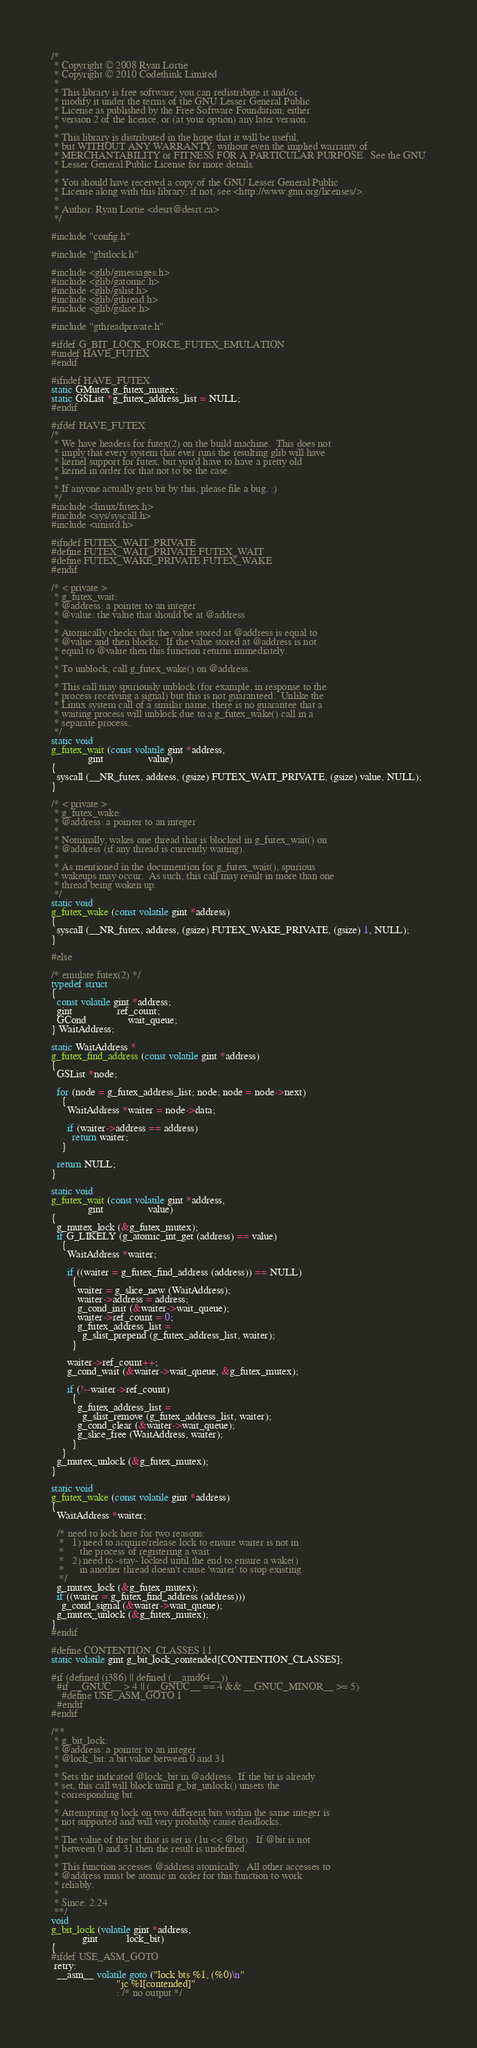<code> <loc_0><loc_0><loc_500><loc_500><_C_>/*
 * Copyright © 2008 Ryan Lortie
 * Copyright © 2010 Codethink Limited
 *
 * This library is free software; you can redistribute it and/or
 * modify it under the terms of the GNU Lesser General Public
 * License as published by the Free Software Foundation; either
 * version 2 of the licence, or (at your option) any later version.
 *
 * This library is distributed in the hope that it will be useful,
 * but WITHOUT ANY WARRANTY; without even the implied warranty of
 * MERCHANTABILITY or FITNESS FOR A PARTICULAR PURPOSE.  See the GNU
 * Lesser General Public License for more details.
 *
 * You should have received a copy of the GNU Lesser General Public
 * License along with this library; if not, see <http://www.gnu.org/licenses/>.
 *
 * Author: Ryan Lortie <desrt@desrt.ca>
 */

#include "config.h"

#include "gbitlock.h"

#include <glib/gmessages.h>
#include <glib/gatomic.h>
#include <glib/gslist.h>
#include <glib/gthread.h>
#include <glib/gslice.h>

#include "gthreadprivate.h"

#ifdef G_BIT_LOCK_FORCE_FUTEX_EMULATION
#undef HAVE_FUTEX
#endif

#ifndef HAVE_FUTEX
static GMutex g_futex_mutex;
static GSList *g_futex_address_list = NULL;
#endif

#ifdef HAVE_FUTEX
/*
 * We have headers for futex(2) on the build machine.  This does not
 * imply that every system that ever runs the resulting glib will have
 * kernel support for futex, but you'd have to have a pretty old
 * kernel in order for that not to be the case.
 *
 * If anyone actually gets bit by this, please file a bug. :)
 */
#include <linux/futex.h>
#include <sys/syscall.h>
#include <unistd.h>

#ifndef FUTEX_WAIT_PRIVATE
#define FUTEX_WAIT_PRIVATE FUTEX_WAIT
#define FUTEX_WAKE_PRIVATE FUTEX_WAKE
#endif

/* < private >
 * g_futex_wait:
 * @address: a pointer to an integer
 * @value: the value that should be at @address
 *
 * Atomically checks that the value stored at @address is equal to
 * @value and then blocks.  If the value stored at @address is not
 * equal to @value then this function returns immediately.
 *
 * To unblock, call g_futex_wake() on @address.
 *
 * This call may spuriously unblock (for example, in response to the
 * process receiving a signal) but this is not guaranteed.  Unlike the
 * Linux system call of a similar name, there is no guarantee that a
 * waiting process will unblock due to a g_futex_wake() call in a
 * separate process.
 */
static void
g_futex_wait (const volatile gint *address,
              gint                 value)
{
  syscall (__NR_futex, address, (gsize) FUTEX_WAIT_PRIVATE, (gsize) value, NULL);
}

/* < private >
 * g_futex_wake:
 * @address: a pointer to an integer
 *
 * Nominally, wakes one thread that is blocked in g_futex_wait() on
 * @address (if any thread is currently waiting).
 *
 * As mentioned in the documention for g_futex_wait(), spurious
 * wakeups may occur.  As such, this call may result in more than one
 * thread being woken up.
 */
static void
g_futex_wake (const volatile gint *address)
{
  syscall (__NR_futex, address, (gsize) FUTEX_WAKE_PRIVATE, (gsize) 1, NULL);
}

#else

/* emulate futex(2) */
typedef struct
{
  const volatile gint *address;
  gint                 ref_count;
  GCond                wait_queue;
} WaitAddress;

static WaitAddress *
g_futex_find_address (const volatile gint *address)
{
  GSList *node;

  for (node = g_futex_address_list; node; node = node->next)
    {
      WaitAddress *waiter = node->data;

      if (waiter->address == address)
        return waiter;
    }

  return NULL;
}

static void
g_futex_wait (const volatile gint *address,
              gint                 value)
{
  g_mutex_lock (&g_futex_mutex);
  if G_LIKELY (g_atomic_int_get (address) == value)
    {
      WaitAddress *waiter;

      if ((waiter = g_futex_find_address (address)) == NULL)
        {
          waiter = g_slice_new (WaitAddress);
          waiter->address = address;
          g_cond_init (&waiter->wait_queue);
          waiter->ref_count = 0;
          g_futex_address_list =
            g_slist_prepend (g_futex_address_list, waiter);
        }

      waiter->ref_count++;
      g_cond_wait (&waiter->wait_queue, &g_futex_mutex);

      if (!--waiter->ref_count)
        {
          g_futex_address_list =
            g_slist_remove (g_futex_address_list, waiter);
          g_cond_clear (&waiter->wait_queue);
          g_slice_free (WaitAddress, waiter);
        }
    }
  g_mutex_unlock (&g_futex_mutex);
}

static void
g_futex_wake (const volatile gint *address)
{
  WaitAddress *waiter;

  /* need to lock here for two reasons:
   *   1) need to acquire/release lock to ensure waiter is not in
   *      the process of registering a wait
   *   2) need to -stay- locked until the end to ensure a wake()
   *      in another thread doesn't cause 'waiter' to stop existing
   */
  g_mutex_lock (&g_futex_mutex);
  if ((waiter = g_futex_find_address (address)))
    g_cond_signal (&waiter->wait_queue);
  g_mutex_unlock (&g_futex_mutex);
}
#endif

#define CONTENTION_CLASSES 11
static volatile gint g_bit_lock_contended[CONTENTION_CLASSES];

#if (defined (i386) || defined (__amd64__))
  #if __GNUC__ > 4 || (__GNUC__ == 4 && __GNUC_MINOR__ >= 5)
    #define USE_ASM_GOTO 1
  #endif
#endif

/**
 * g_bit_lock:
 * @address: a pointer to an integer
 * @lock_bit: a bit value between 0 and 31
 *
 * Sets the indicated @lock_bit in @address.  If the bit is already
 * set, this call will block until g_bit_unlock() unsets the
 * corresponding bit.
 *
 * Attempting to lock on two different bits within the same integer is
 * not supported and will very probably cause deadlocks.
 *
 * The value of the bit that is set is (1u << @bit).  If @bit is not
 * between 0 and 31 then the result is undefined.
 *
 * This function accesses @address atomically.  All other accesses to
 * @address must be atomic in order for this function to work
 * reliably.
 *
 * Since: 2.24
 **/
void
g_bit_lock (volatile gint *address,
            gint           lock_bit)
{
#ifdef USE_ASM_GOTO
 retry:
  __asm__ volatile goto ("lock bts %1, (%0)\n"
                         "jc %l[contended]"
                         : /* no output */</code> 